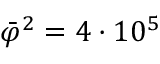<formula> <loc_0><loc_0><loc_500><loc_500>\bar { \varphi } ^ { 2 } = 4 \cdot 1 0 ^ { 5 }</formula> 